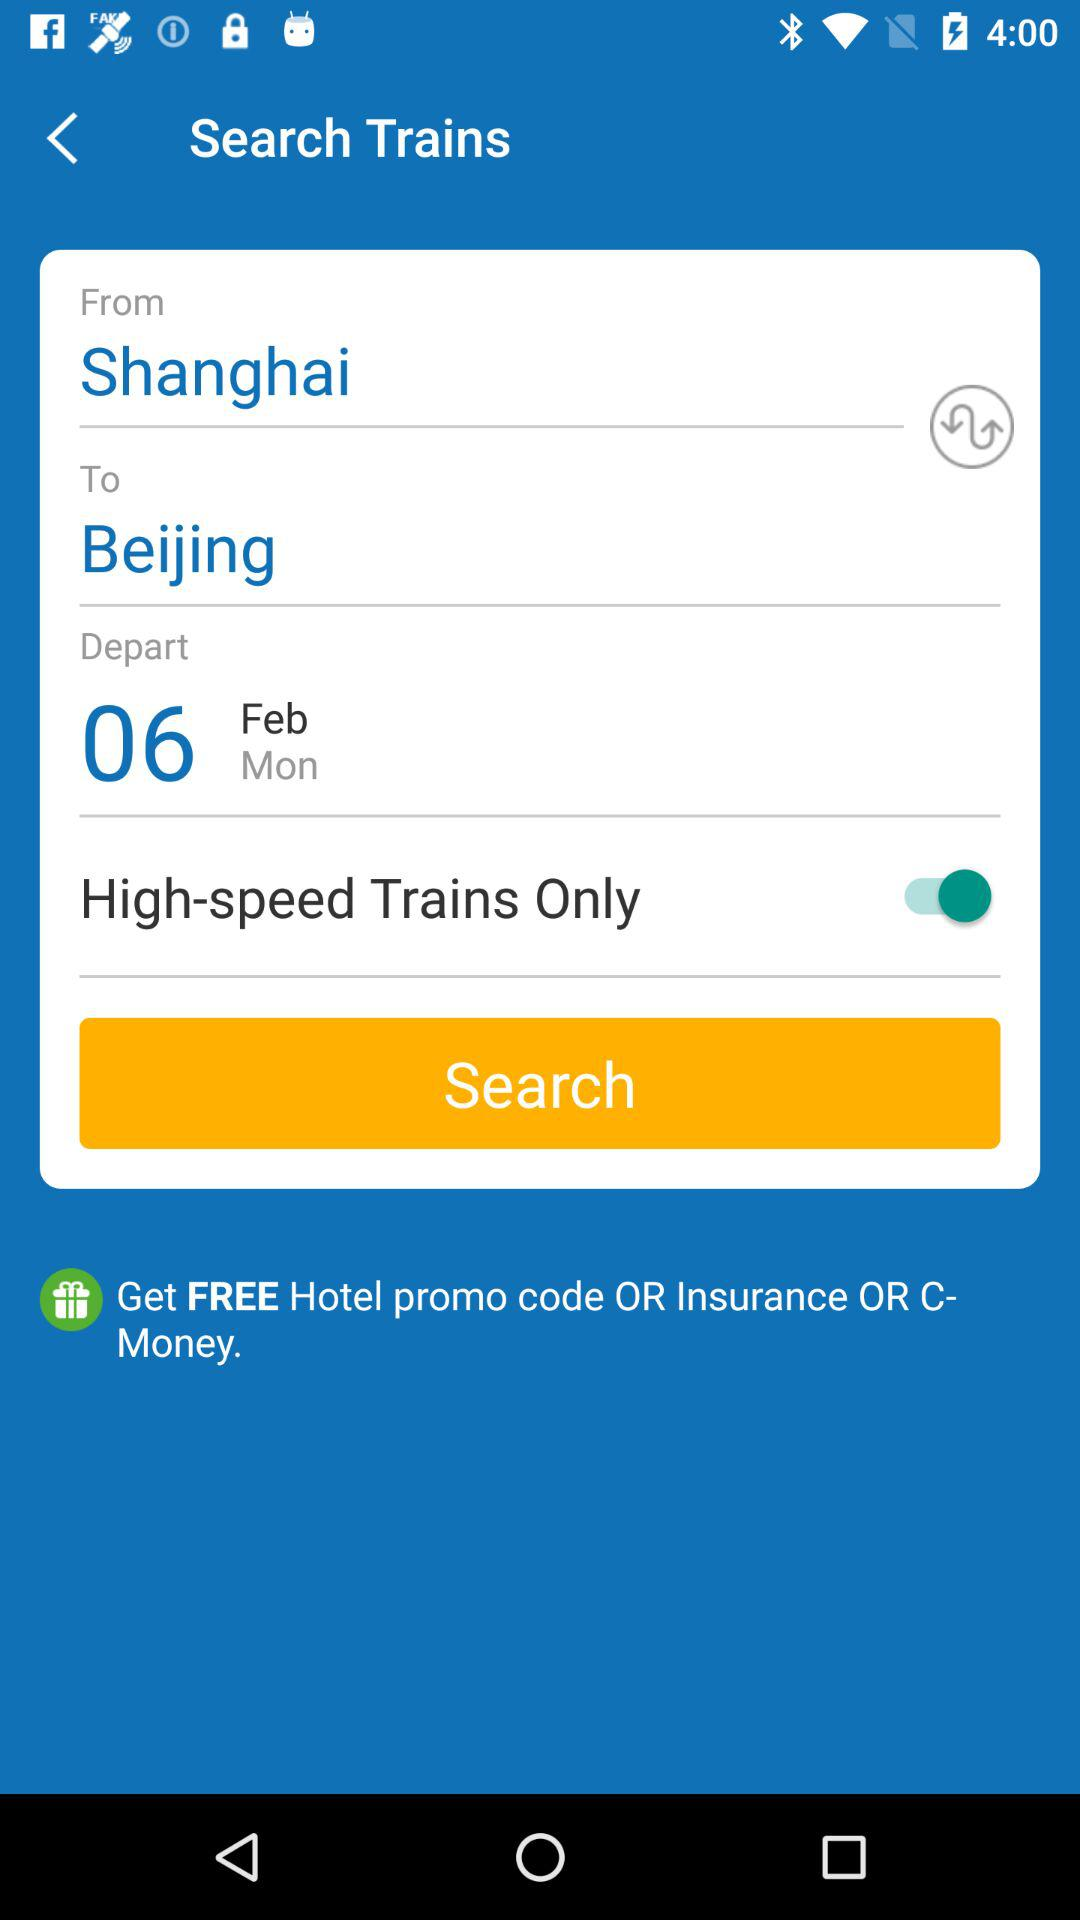What type of train does the user want? The user wants high-speed trains only. 